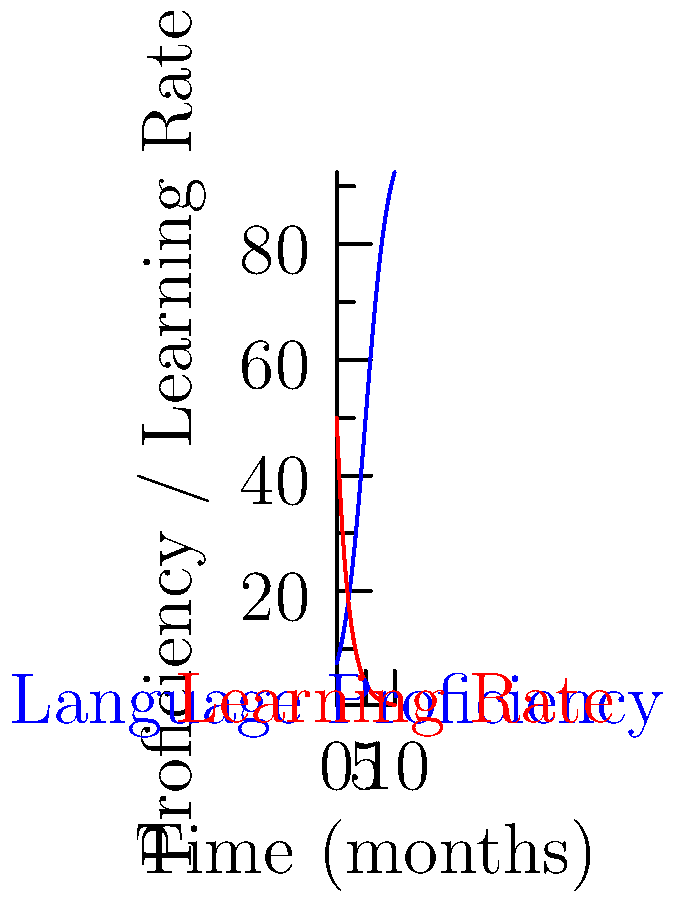The graph shows the language proficiency curve (blue) and the corresponding learning rate curve (red) for a typical language learner over time. At which point in time does the learning rate decrease most rapidly? To find the point where the learning rate decreases most rapidly, we need to analyze the red curve (learning rate) and determine where its slope is the steepest in the negative direction.

Step 1: Observe the learning rate curve (red).
The curve starts high and decreases exponentially over time.

Step 2: Identify the steepest part of the curve.
The steepest part of an exponential decay curve is at the beginning, where the rate of change is greatest.

Step 3: Relate to the language proficiency curve (blue).
Notice that the steepest decrease in learning rate corresponds to the early stages of language learning, where the proficiency curve is just beginning to rise rapidly.

Step 4: Estimate the time point.
The learning rate curve is steepest at the very beginning, around 0-1 months.

Therefore, the learning rate decreases most rapidly at the start of the language learning process, approximately at time t = 0 months.
Answer: t = 0 months 